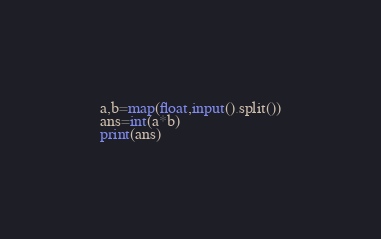<code> <loc_0><loc_0><loc_500><loc_500><_Python_>a,b=map(float,input().split())
ans=int(a*b)
print(ans)</code> 